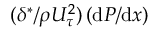<formula> <loc_0><loc_0><loc_500><loc_500>( \delta ^ { * } / { \rho U _ { \tau } ^ { 2 } } ) \left ( d P / d x \right )</formula> 